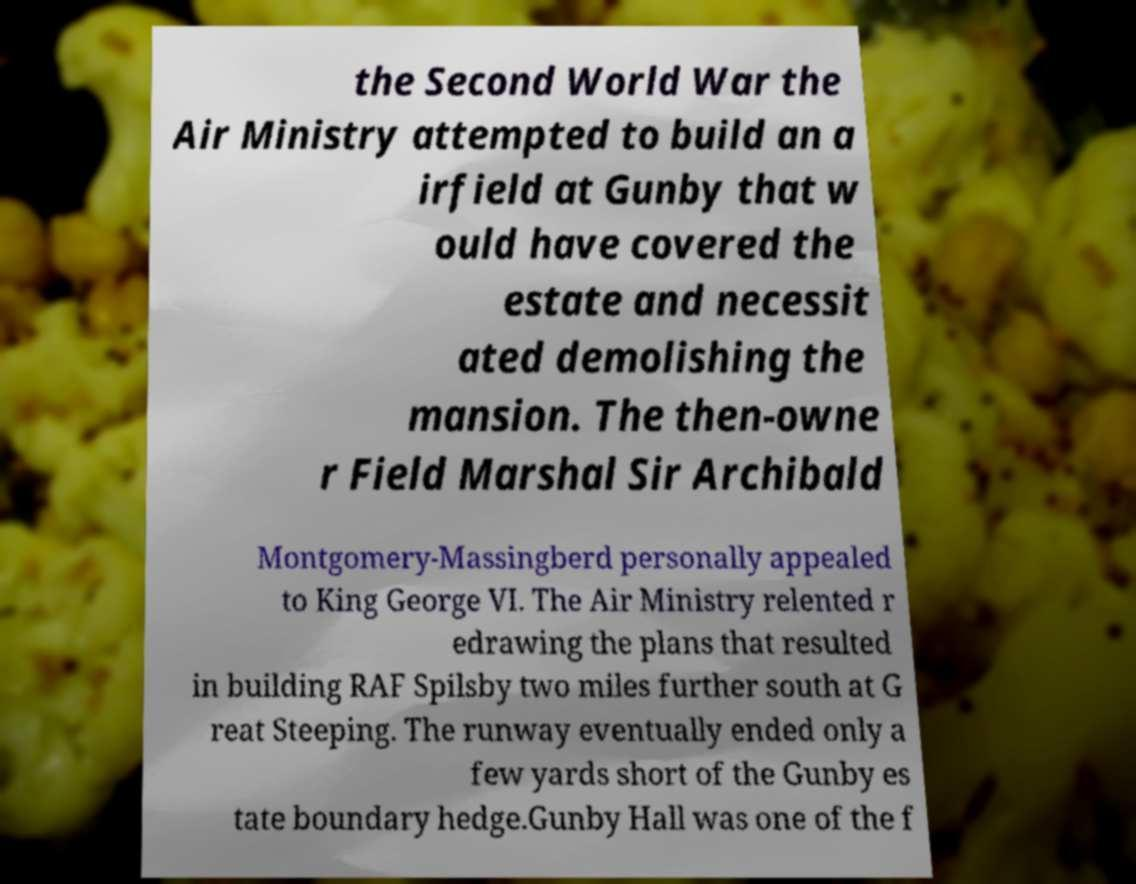Can you accurately transcribe the text from the provided image for me? the Second World War the Air Ministry attempted to build an a irfield at Gunby that w ould have covered the estate and necessit ated demolishing the mansion. The then-owne r Field Marshal Sir Archibald Montgomery-Massingberd personally appealed to King George VI. The Air Ministry relented r edrawing the plans that resulted in building RAF Spilsby two miles further south at G reat Steeping. The runway eventually ended only a few yards short of the Gunby es tate boundary hedge.Gunby Hall was one of the f 